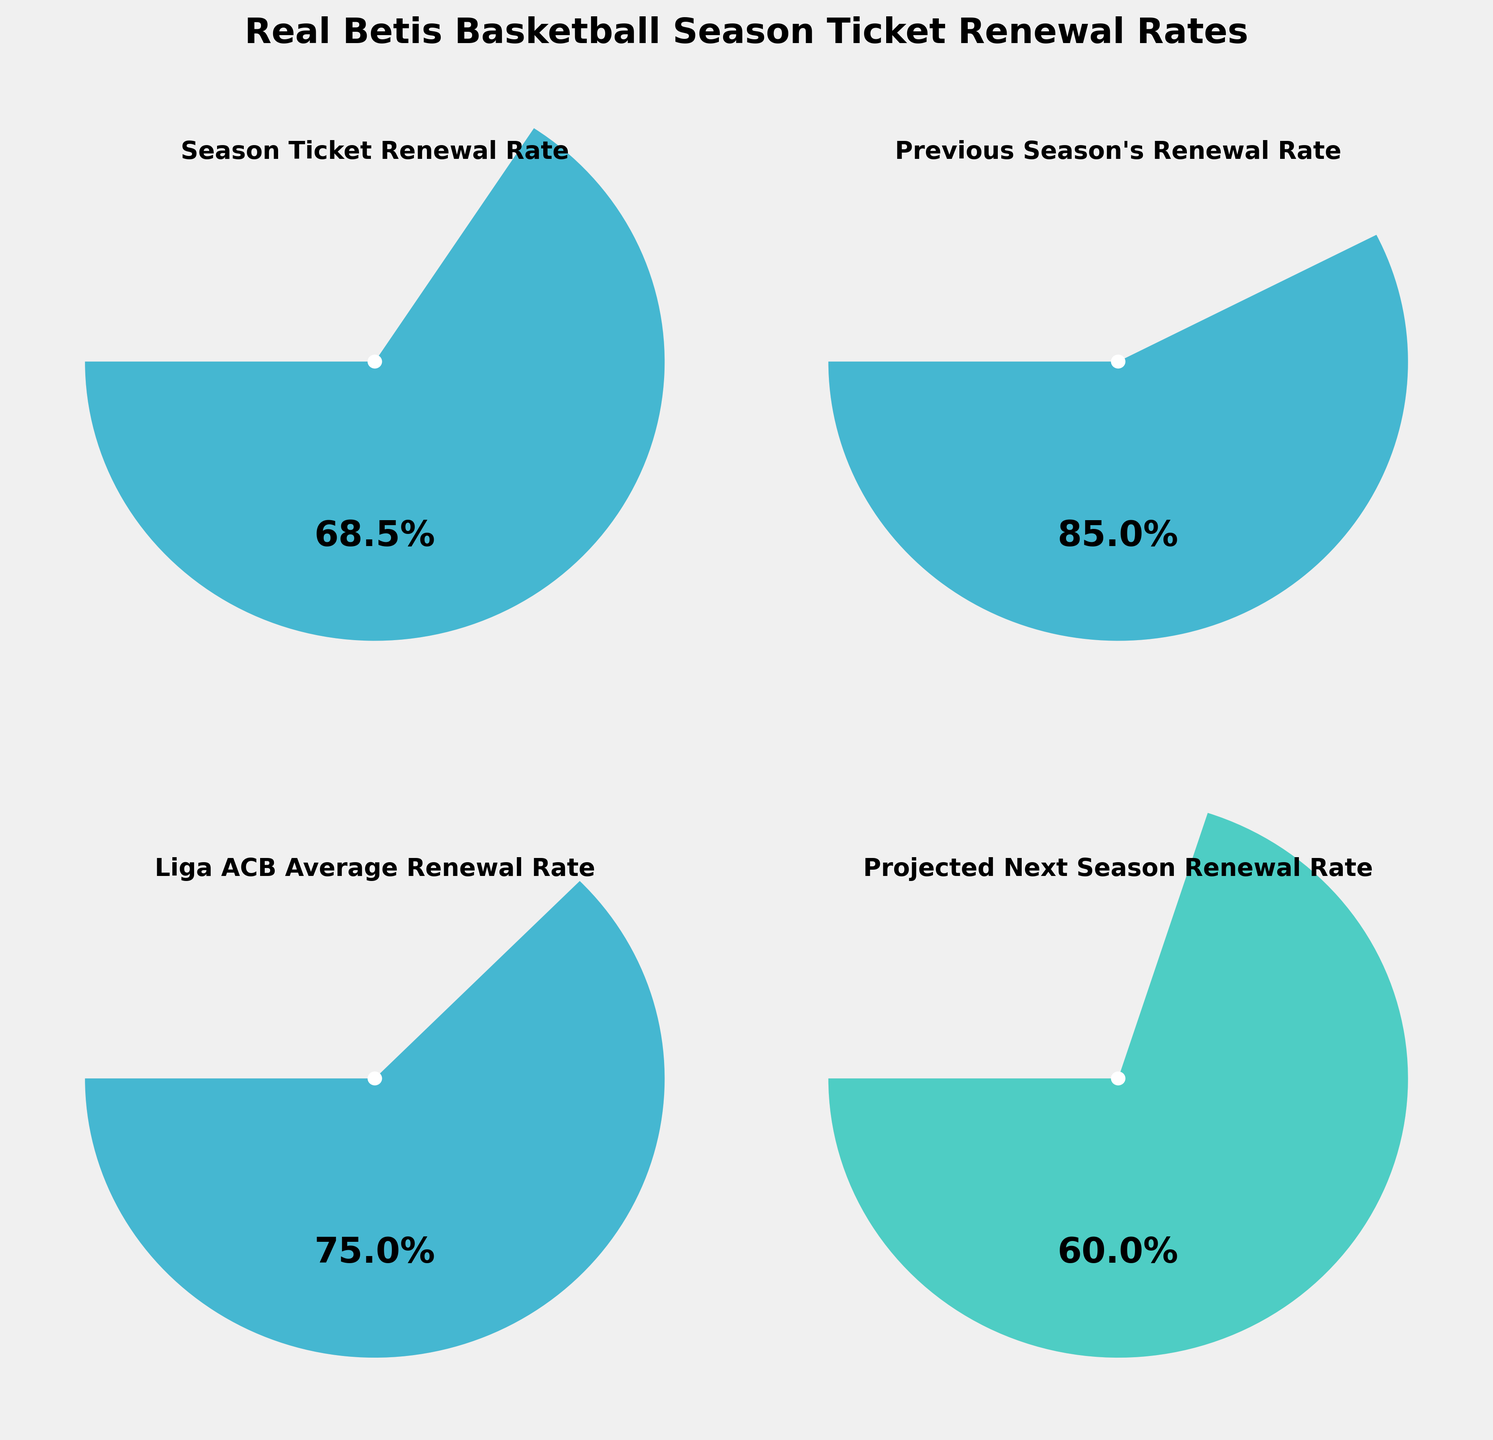What's the title of the figure? The title is usually displayed at the top of the figure, summarizing the overall content. Here, the title is "Real Betis Basketball Season Ticket Renewal Rates" as it is the main heading visible on the figure.
Answer: Real Betis Basketball Season Ticket Renewal Rates What is the renewal rate for the current season? The current season's renewal rate is specified in one of the gauge charts within the figure. It is labeled "Season Ticket Renewal Rate" and shows 68.5%.
Answer: 68.5% How does the current season's renewal rate compare to the previous season's? To compare the current and previous season, separately check "Season Ticket Renewal Rate" which is 68.5% and "Previous Season's Renewal Rate" which is 85%. Clearly, 68.5% is less than 85%.
Answer: 68.5% is less than 85% What's the average renewal rate for the Liga ACB? Locate the gauge labeled "Liga ACB Average Renewal Rate" which indicates the average renewal rate. The gauge shows 75%.
Answer: 75% What is the projected renewal rate for the next season? Check the gauge labeled "Projected Next Season Renewal Rate," which shows the future projection. It displays a value of 60%.
Answer: 60% By how much did the renewal rate drop from the previous season to the current season? Subtract the current season's rate from the previous season's rate: 85% - 68.5% = 16.5%. This indicates a drop of 16.5%.
Answer: 16.5% Which renewal rate is the lowest among those shown in the figure? Compare all displayed renewal rates: 68.5%, 85%, 75%, and 60%. The lowest value is 60%, the projected next season's rate.
Answer: 60% How does the current season's renewal rate compare to the Liga ACB average? The current season's renewal rate is 68.5%, while the Liga ACB average is 75%. Thus, the current season is lower than the average.
Answer: 68.5% is less than 75% What is the difference between the Liga ACB average renewal rate and the projected next season renewal rate? Subtract the projected rate from the Liga ACB average: 75% - 60% = 15%. So the difference is 15%.
Answer: 15% If the projected next season's renewal rate is achieved, how will it compare to the current season's rate? Compare 60% (projected) with 68.5% (current). Since 60% is less than 68.5%, it will be lower than the current season's rate.
Answer: It will be lower 